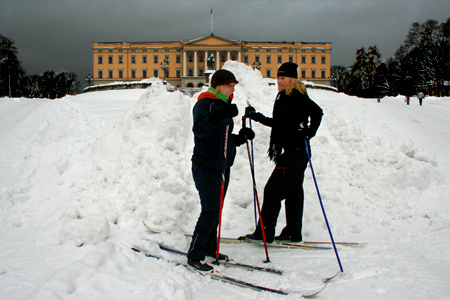What is the color of the jacket that the girl is in? The color of the jacket that the girl is wearing is black. 